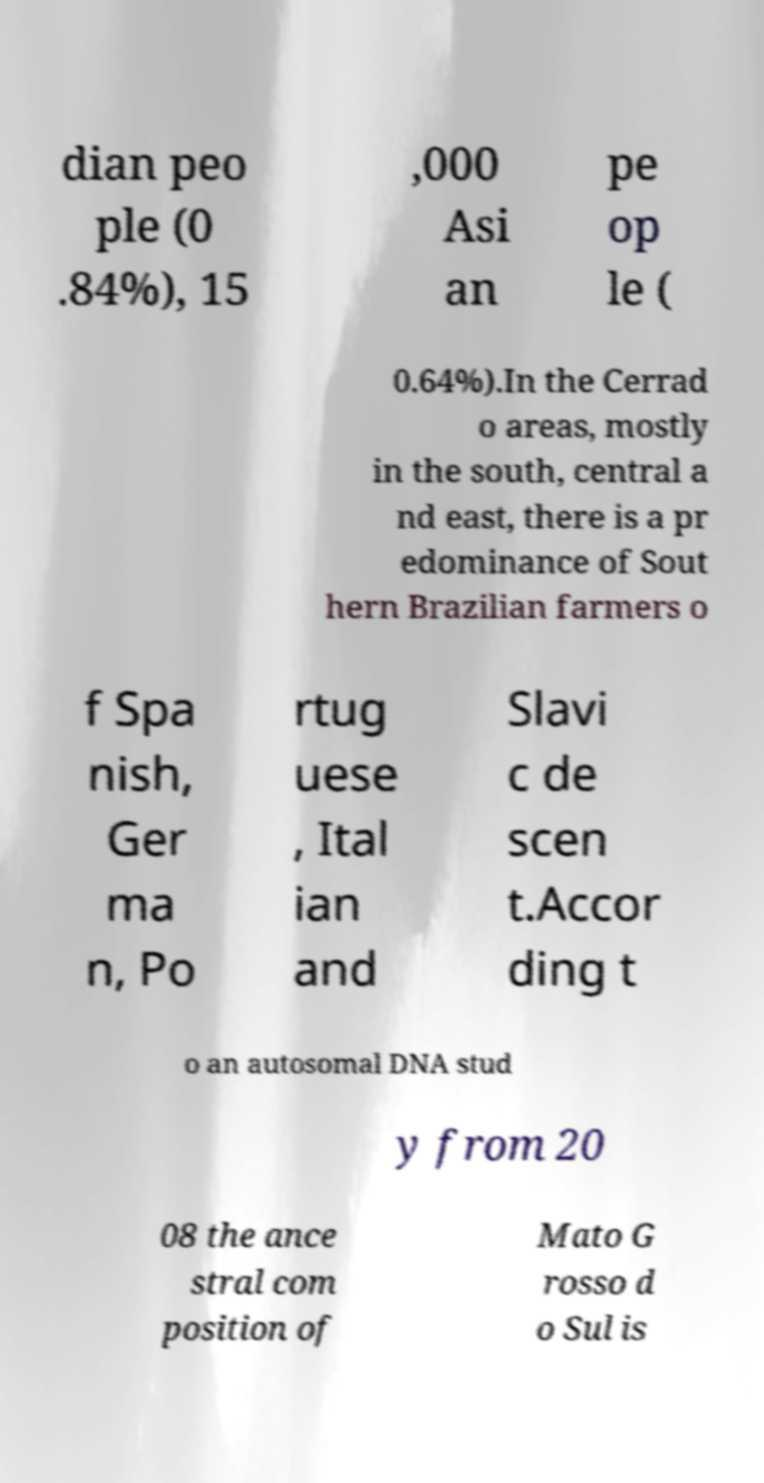What messages or text are displayed in this image? I need them in a readable, typed format. dian peo ple (0 .84%), 15 ,000 Asi an pe op le ( 0.64%).In the Cerrad o areas, mostly in the south, central a nd east, there is a pr edominance of Sout hern Brazilian farmers o f Spa nish, Ger ma n, Po rtug uese , Ital ian and Slavi c de scen t.Accor ding t o an autosomal DNA stud y from 20 08 the ance stral com position of Mato G rosso d o Sul is 